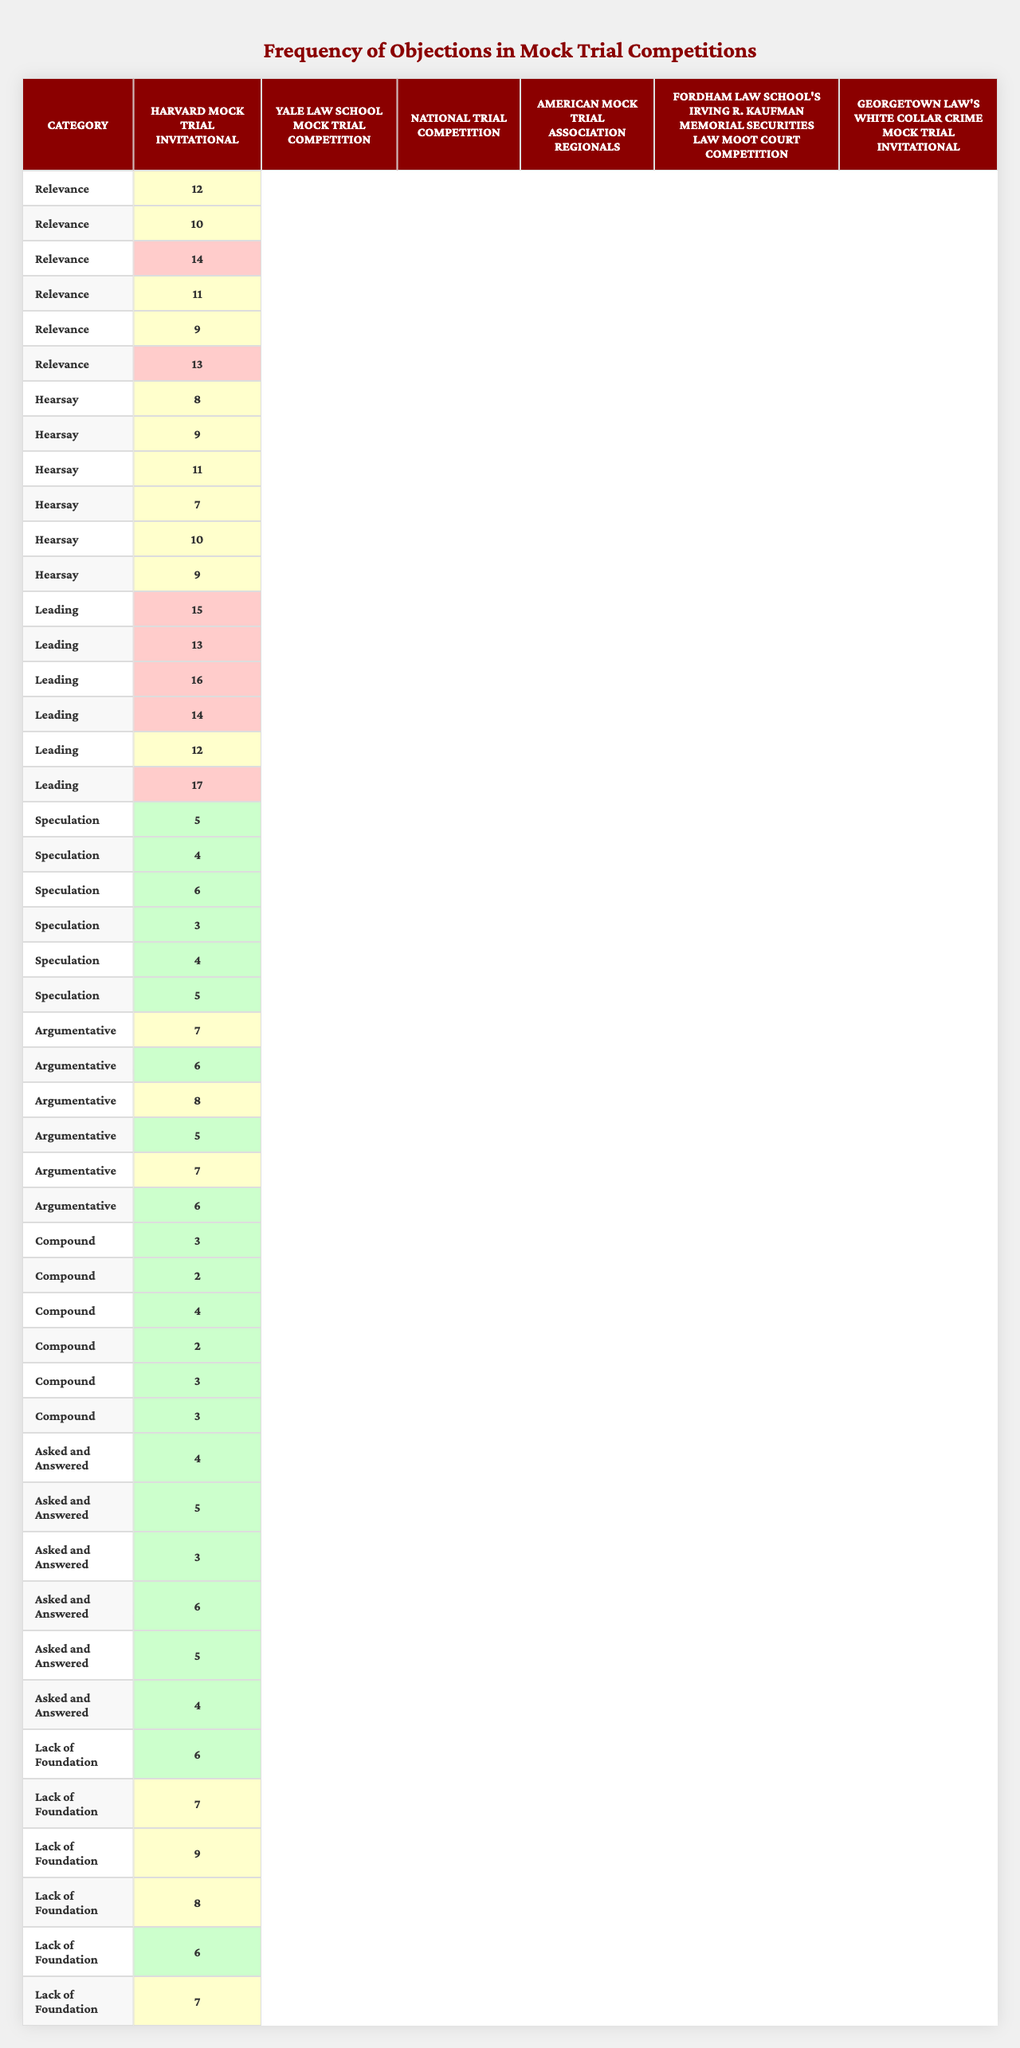What is the frequency of objections related to "Hearsay" in the "National Trial Competition"? Referring to the table under the "National Trial Competition" column, the frequency of objections for the "Hearsay" category is found in the specific row corresponding to Hearsay. The value in the intersection is 11.
Answer: 11 Which category had the highest frequency of objections in the "Yale Law School Mock Trial Competition"? Looking at the "Yale Law School Mock Trial Competition" column and analyzing the frequencies across all categories, the maximum value is 13 under the "Leading" category.
Answer: Leading What was the average frequency of objections for the "Speculation" category across all competitions? Adding the frequencies for the "Speculation" category from all competitions gives (5 + 4 + 6 + 3 + 4 + 5) = 27. Then, dividing this sum by the number of competitions (6) results in an average of 27/6 = 4.5.
Answer: 4.5 Which competition had the lowest total number of objections raised across all categories? To find the lowest total objections, calculate the sum of frequencies for each competition. The sums are 55, 54, 66, 50, 46, and 60 for each competition respectively. The competition with the lowest sum is the "American Mock Trial Association Regionals" with 50 total objections.
Answer: American Mock Trial Association Regionals Is the frequency of "Leading" objections in "Georgetown Law's White Collar Crime Mock Trial Invitational" higher than in "Fordham Law School's Irving R. Kaufman Memorial Securities Law Moot Court Competition"? The frequency for "Leading" in "Georgetown" is 17, while for "Fordham" it is 12. Since 17 is greater than 12, yes, the frequency of "Leading" objections in Georgetown is higher.
Answer: Yes What is the total frequency of "Relevance" objections across all competitions? Summing the "Relevance" frequencies for all competitions gives (12 + 10 + 14 + 11 + 9 + 13) = 69.
Answer: 69 Which category had the least total objections raised across all competitions? Calculate the total objections for each category: (12+10+14+11+9+13 = 69 for Relevance), (8+9+11+7+10+9 = 54 for Hearsay), (15+13+16+14+12+17 = 87 for Leading), (5+4+6+3+4+5 = 27 for Speculation), (7+6+8+5+7+6 = 39 for Argumentative), (3+2+4+2+3+3 = 17 for Compound), (4+5+3+6+5+4 = 27 for Asked and Answered), and (6+7+9+8+6+7 = 43 for Lack of Foundation). The category with the least total is "Compound" with 17 objections.
Answer: Compound How does the frequency of "Argumentative" objections in "Harvard Mock Trial Invitational" compare to all other competitions? The number of "Argumentative" objections in Harvard is 7. Comparing this to other competitions: 6 (Yale), 8 (National), 5 (American), 7 (Fordham), and 6 (Georgetown), only "National Trial Competition" has higher frequency (8). Hence, "Harvard" is tied for second place with Fordham.
Answer: Tied for second place What is the median frequency of objections for the "Lack of Foundation" category? First, extract the frequencies for "Lack of Foundation": 6, 7, 3, 8, 6, 4. Sort these frequencies: 3, 4, 6, 6, 7, 8. Since there are six values, the median is the average of the 3rd and 4th values: (6 + 6) / 2 = 6.
Answer: 6 